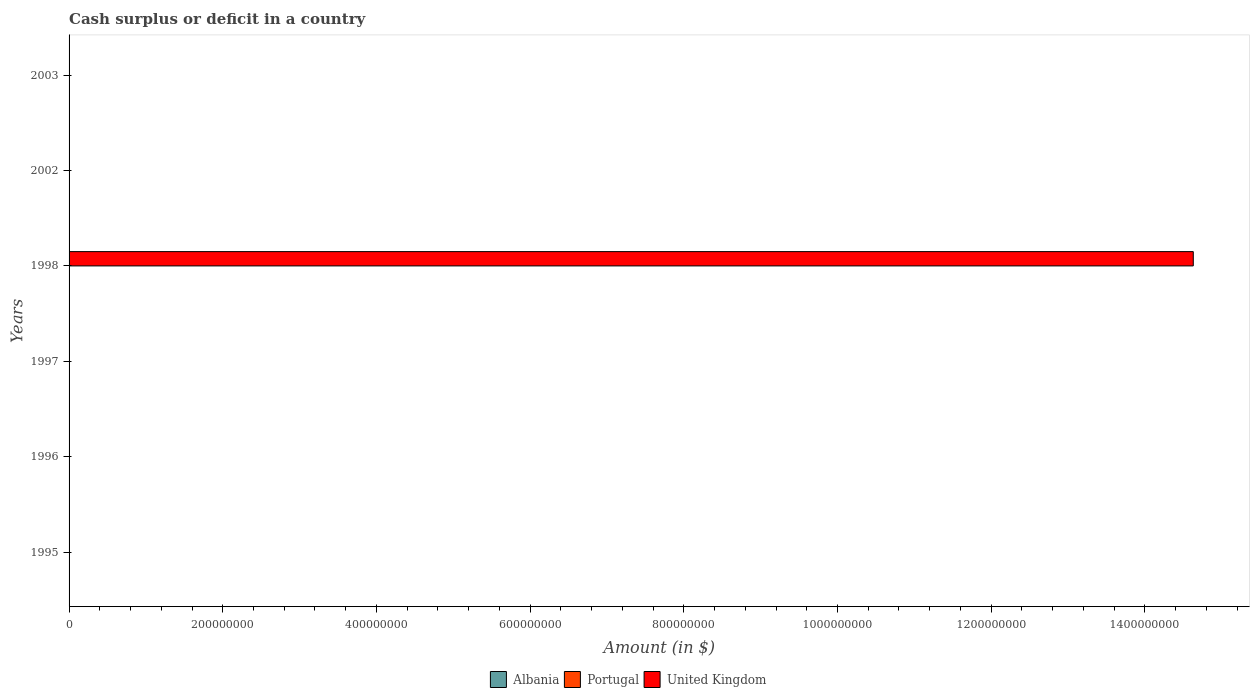Are the number of bars on each tick of the Y-axis equal?
Keep it short and to the point. No. How many bars are there on the 2nd tick from the bottom?
Provide a short and direct response. 0. In how many cases, is the number of bars for a given year not equal to the number of legend labels?
Ensure brevity in your answer.  6. What is the amount of cash surplus or deficit in United Kingdom in 1996?
Your answer should be very brief. 0. Across all years, what is the minimum amount of cash surplus or deficit in Portugal?
Keep it short and to the point. 0. In which year was the amount of cash surplus or deficit in United Kingdom maximum?
Provide a short and direct response. 1998. What is the difference between the amount of cash surplus or deficit in Albania in 1996 and the amount of cash surplus or deficit in Portugal in 2002?
Provide a succinct answer. 0. What is the average amount of cash surplus or deficit in Albania per year?
Make the answer very short. 0. In how many years, is the amount of cash surplus or deficit in United Kingdom greater than 1160000000 $?
Your answer should be very brief. 1. What is the difference between the highest and the lowest amount of cash surplus or deficit in United Kingdom?
Your answer should be compact. 1.46e+09. In how many years, is the amount of cash surplus or deficit in Portugal greater than the average amount of cash surplus or deficit in Portugal taken over all years?
Give a very brief answer. 0. How many bars are there?
Offer a very short reply. 1. Are all the bars in the graph horizontal?
Your answer should be very brief. Yes. How many years are there in the graph?
Offer a terse response. 6. What is the difference between two consecutive major ticks on the X-axis?
Ensure brevity in your answer.  2.00e+08. Does the graph contain grids?
Offer a terse response. No. Where does the legend appear in the graph?
Offer a very short reply. Bottom center. How are the legend labels stacked?
Keep it short and to the point. Horizontal. What is the title of the graph?
Your response must be concise. Cash surplus or deficit in a country. What is the label or title of the X-axis?
Give a very brief answer. Amount (in $). What is the Amount (in $) in Albania in 1995?
Make the answer very short. 0. What is the Amount (in $) in Albania in 1997?
Your answer should be very brief. 0. What is the Amount (in $) of Albania in 1998?
Make the answer very short. 0. What is the Amount (in $) of Portugal in 1998?
Provide a short and direct response. 0. What is the Amount (in $) in United Kingdom in 1998?
Keep it short and to the point. 1.46e+09. What is the Amount (in $) of Albania in 2002?
Your answer should be very brief. 0. What is the Amount (in $) of United Kingdom in 2002?
Your answer should be very brief. 0. What is the Amount (in $) in Albania in 2003?
Your response must be concise. 0. What is the Amount (in $) of Portugal in 2003?
Keep it short and to the point. 0. What is the Amount (in $) of United Kingdom in 2003?
Your answer should be compact. 0. Across all years, what is the maximum Amount (in $) in United Kingdom?
Offer a very short reply. 1.46e+09. What is the total Amount (in $) in United Kingdom in the graph?
Your answer should be compact. 1.46e+09. What is the average Amount (in $) in Albania per year?
Keep it short and to the point. 0. What is the average Amount (in $) in Portugal per year?
Your answer should be compact. 0. What is the average Amount (in $) in United Kingdom per year?
Your answer should be compact. 2.44e+08. What is the difference between the highest and the lowest Amount (in $) in United Kingdom?
Keep it short and to the point. 1.46e+09. 